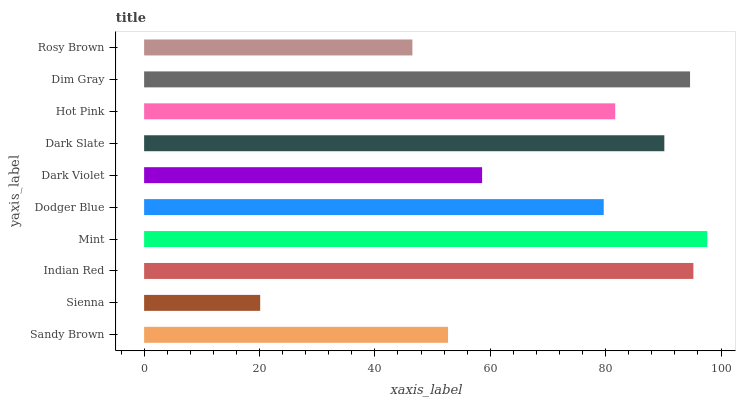Is Sienna the minimum?
Answer yes or no. Yes. Is Mint the maximum?
Answer yes or no. Yes. Is Indian Red the minimum?
Answer yes or no. No. Is Indian Red the maximum?
Answer yes or no. No. Is Indian Red greater than Sienna?
Answer yes or no. Yes. Is Sienna less than Indian Red?
Answer yes or no. Yes. Is Sienna greater than Indian Red?
Answer yes or no. No. Is Indian Red less than Sienna?
Answer yes or no. No. Is Hot Pink the high median?
Answer yes or no. Yes. Is Dodger Blue the low median?
Answer yes or no. Yes. Is Rosy Brown the high median?
Answer yes or no. No. Is Dark Slate the low median?
Answer yes or no. No. 